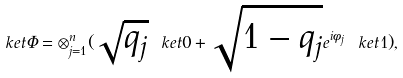Convert formula to latex. <formula><loc_0><loc_0><loc_500><loc_500>\ k e t { \Phi } = \otimes _ { j = 1 } ^ { n } ( \sqrt { q _ { j } } \ k e t { 0 } + \sqrt { 1 - q _ { j } } e ^ { i \phi _ { j } } \ k e t { 1 } ) ,</formula> 